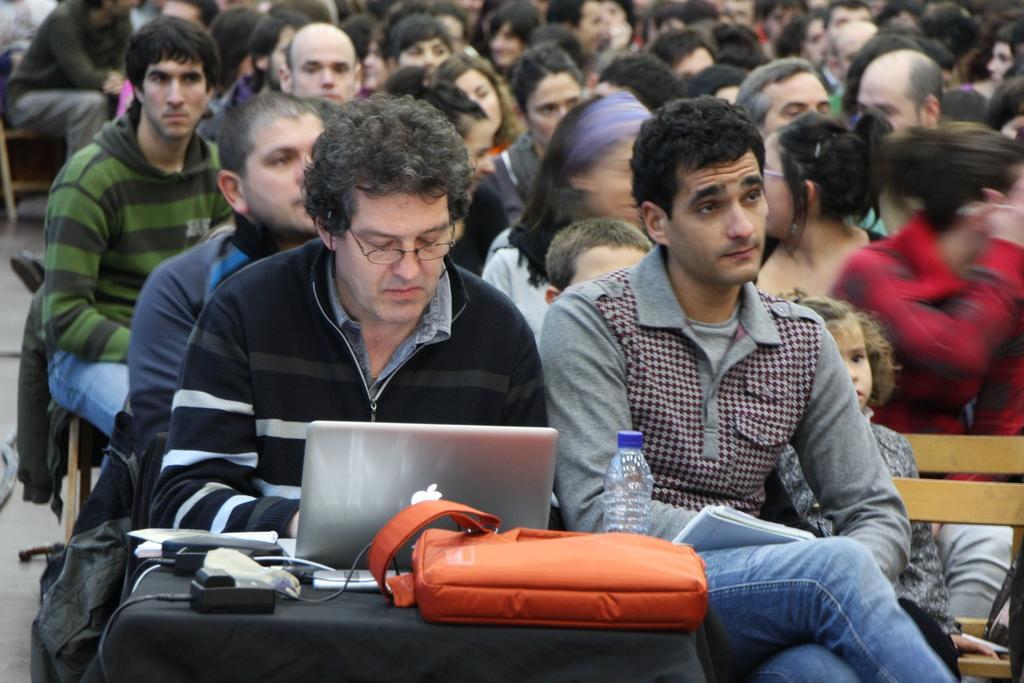In one or two sentences, can you explain what this image depicts? In the center of the image we can see two persons sitting on the bench. At the table we can see laptop, bag, bottle and charger. In the background there are group of persons. 